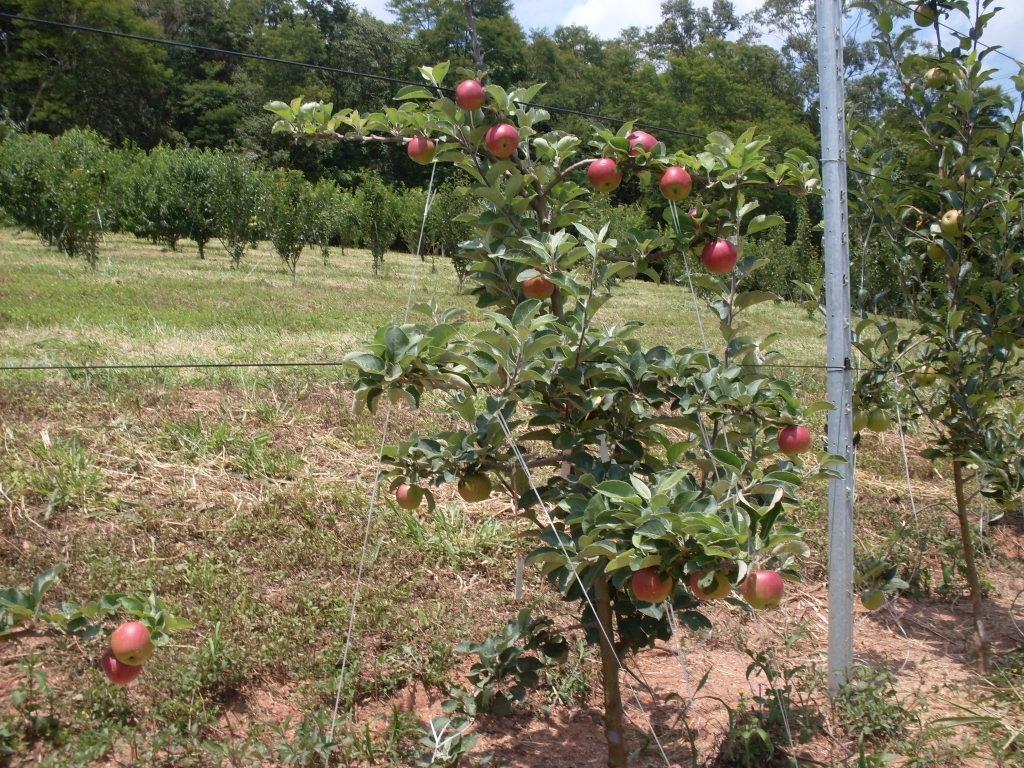Can you describe this image briefly? In this picture I can see trees and I can see apples to the trees and I can see grass on the ground and a blue cloudy sky. 